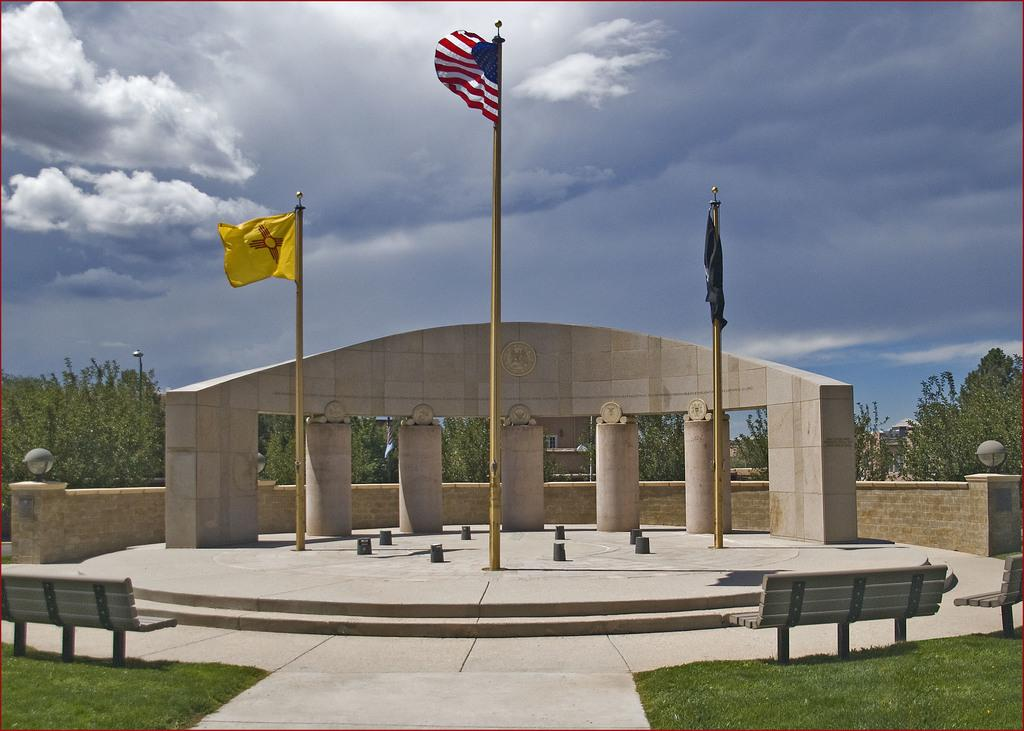How many flags can be seen in the image? There are three flags in the image. What other objects are present in the image besides the flags? There are benches in the image. What type of natural elements can be seen in the image? Trees are present on the ground in the image. What type of slip can be seen on the ground in the image? There is no slip present in the image; it features three flags, benches, and trees. 